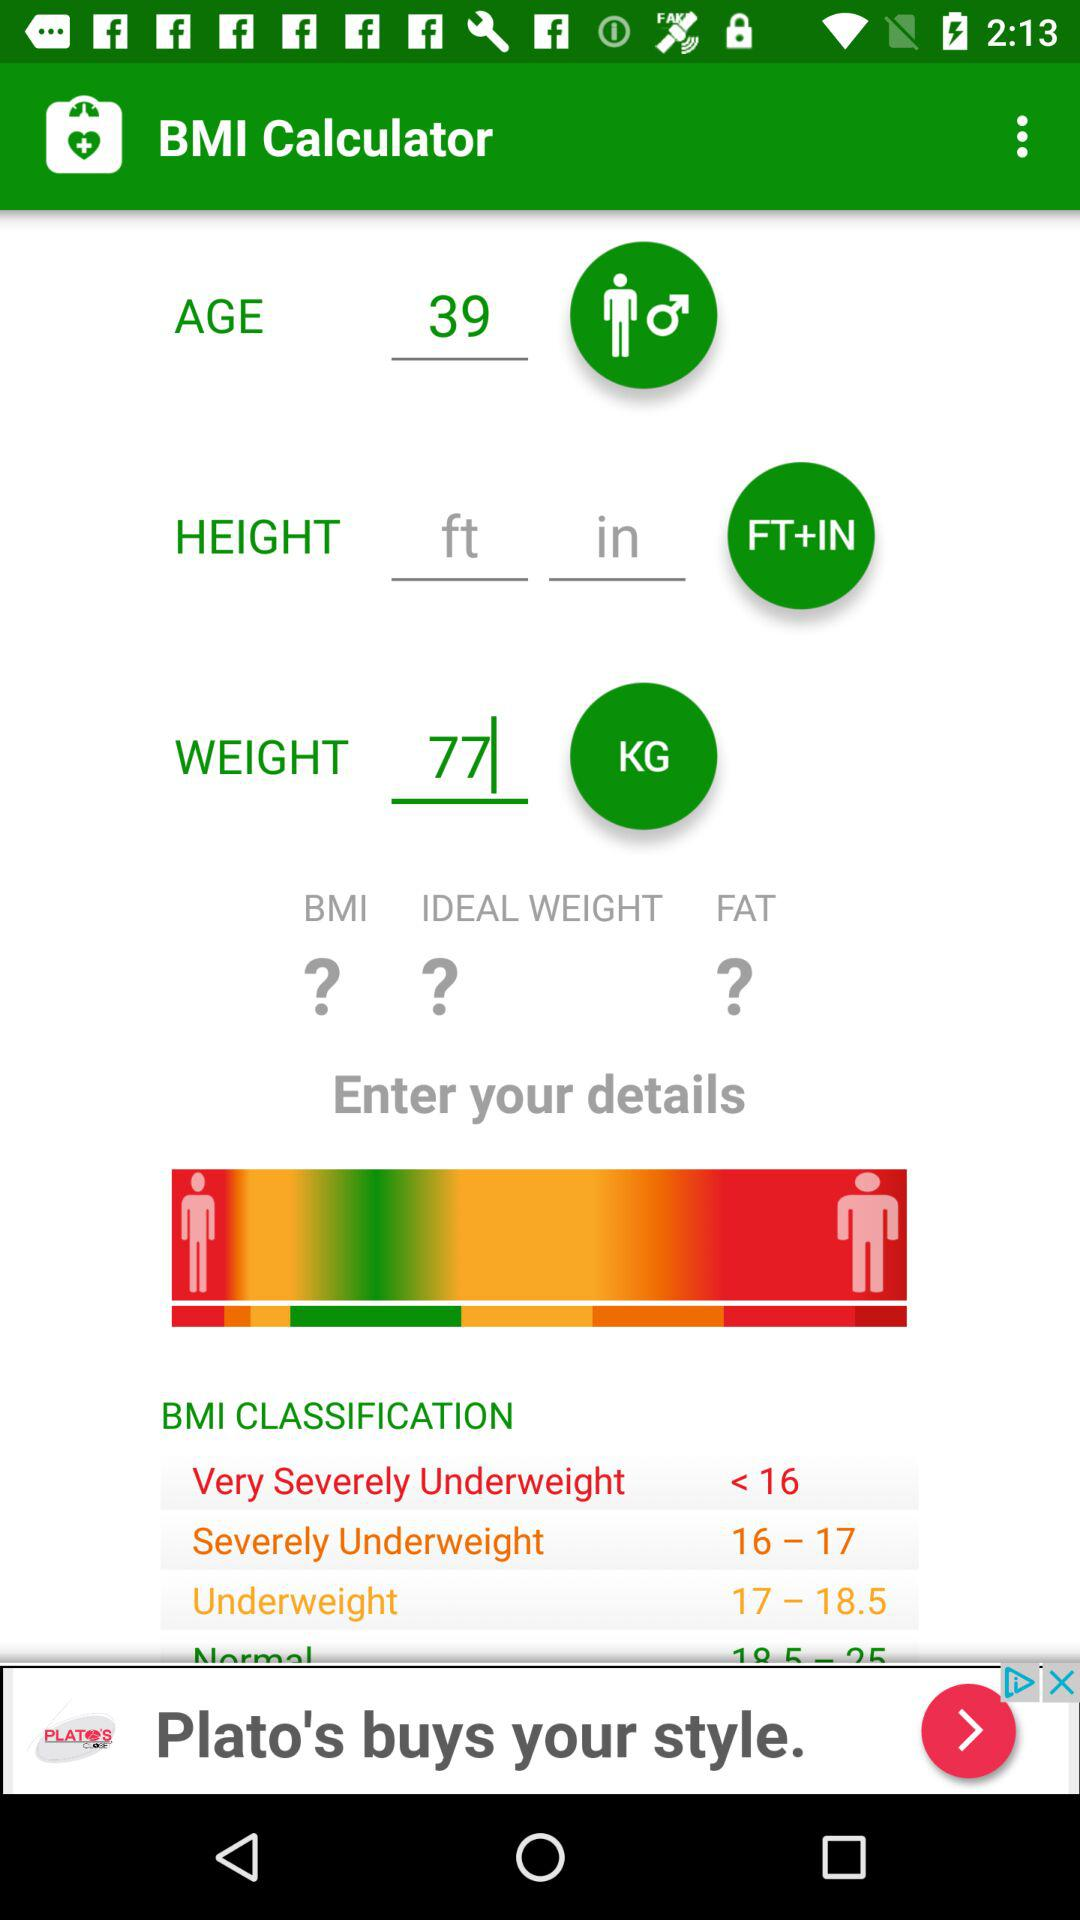How tall is the user?
When the provided information is insufficient, respond with <no answer>. <no answer> 